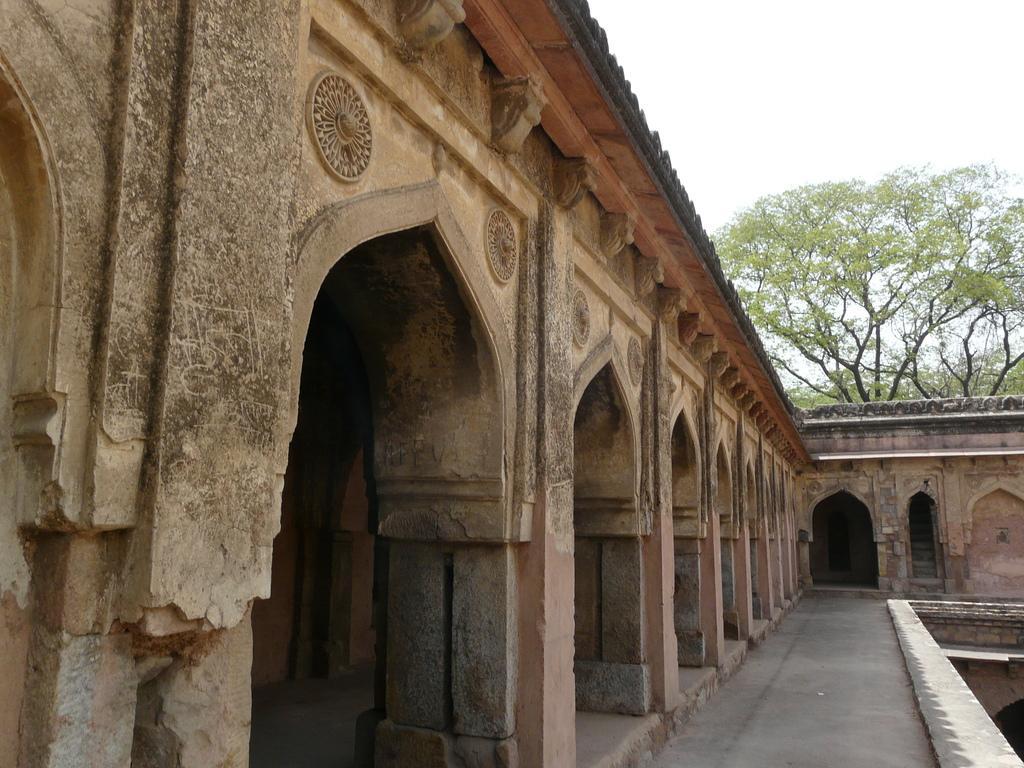In one or two sentences, can you explain what this image depicts? In this image, we can see some arches with some sculptures. We can also see the wall. We can see some trees and the sky. 